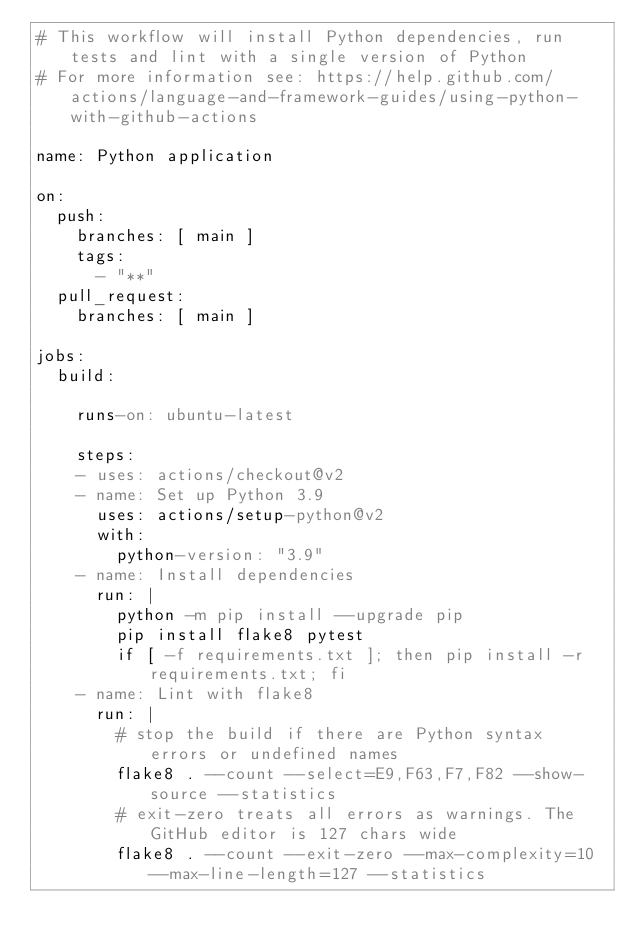<code> <loc_0><loc_0><loc_500><loc_500><_YAML_># This workflow will install Python dependencies, run tests and lint with a single version of Python
# For more information see: https://help.github.com/actions/language-and-framework-guides/using-python-with-github-actions

name: Python application

on:
  push:
    branches: [ main ]
    tags:
      - "**"
  pull_request:
    branches: [ main ]

jobs:
  build:

    runs-on: ubuntu-latest

    steps:
    - uses: actions/checkout@v2
    - name: Set up Python 3.9
      uses: actions/setup-python@v2
      with:
        python-version: "3.9"
    - name: Install dependencies
      run: |
        python -m pip install --upgrade pip
        pip install flake8 pytest
        if [ -f requirements.txt ]; then pip install -r requirements.txt; fi
    - name: Lint with flake8
      run: |
        # stop the build if there are Python syntax errors or undefined names
        flake8 . --count --select=E9,F63,F7,F82 --show-source --statistics
        # exit-zero treats all errors as warnings. The GitHub editor is 127 chars wide
        flake8 . --count --exit-zero --max-complexity=10 --max-line-length=127 --statistics
</code> 